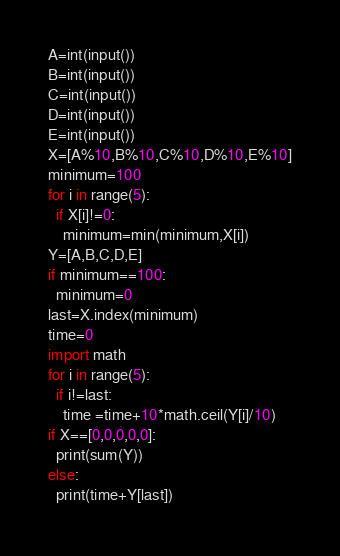<code> <loc_0><loc_0><loc_500><loc_500><_Python_>A=int(input())
B=int(input())
C=int(input())
D=int(input())
E=int(input())
X=[A%10,B%10,C%10,D%10,E%10]
minimum=100
for i in range(5):
  if X[i]!=0:
    minimum=min(minimum,X[i])
Y=[A,B,C,D,E]
if minimum==100:
  minimum=0
last=X.index(minimum)
time=0
import math
for i in range(5):
  if i!=last:
    time =time+10*math.ceil(Y[i]/10)
if X==[0,0,0,0,0]:
  print(sum(Y))
else:
  print(time+Y[last])</code> 